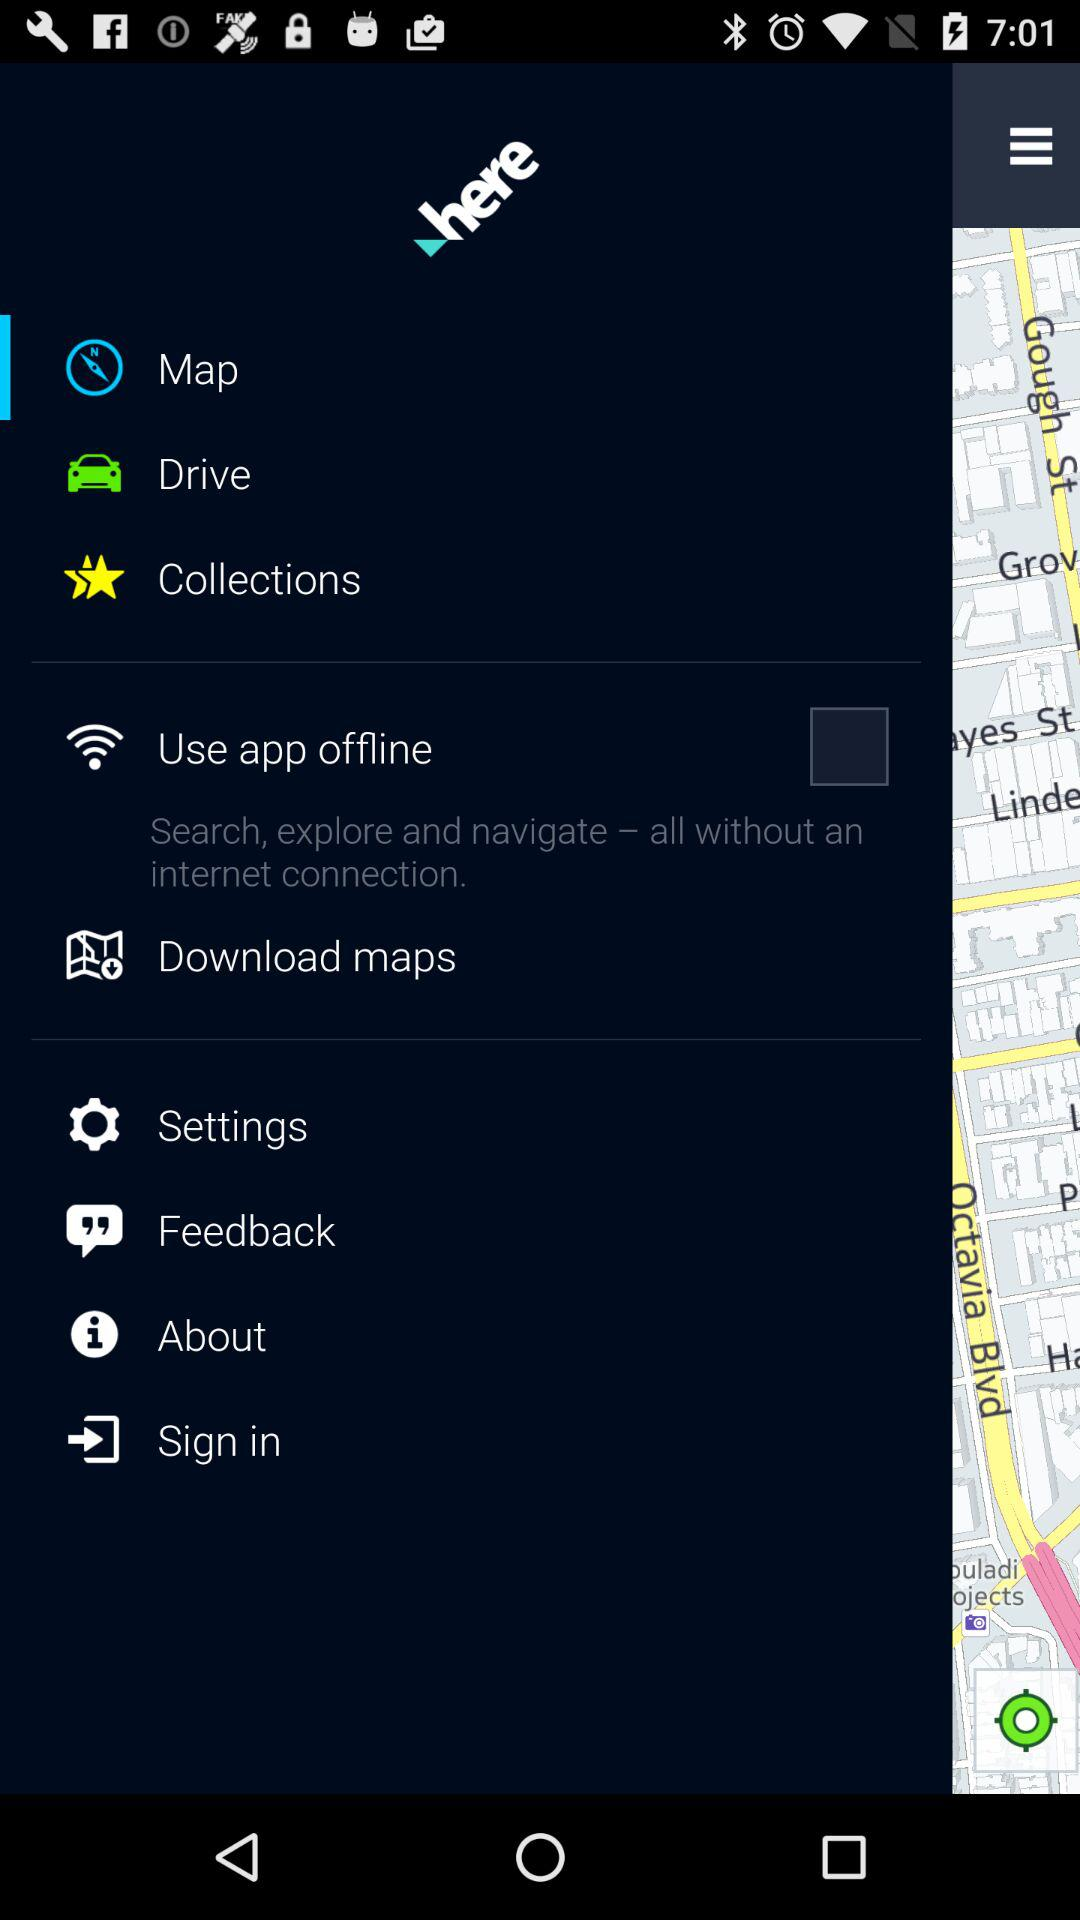What is the status of the "Use app offline"? The status of the "Use app offline" is "off". 